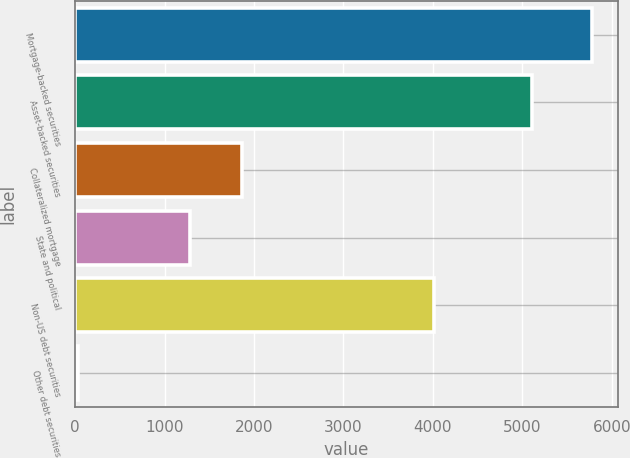Convert chart to OTSL. <chart><loc_0><loc_0><loc_500><loc_500><bar_chart><fcel>Mortgage-backed securities<fcel>Asset-backed securities<fcel>Collateralized mortgage<fcel>State and political<fcel>Non-US debt securities<fcel>Other debt securities<nl><fcel>5776<fcel>5111<fcel>1863.2<fcel>1289<fcel>4007<fcel>34<nl></chart> 